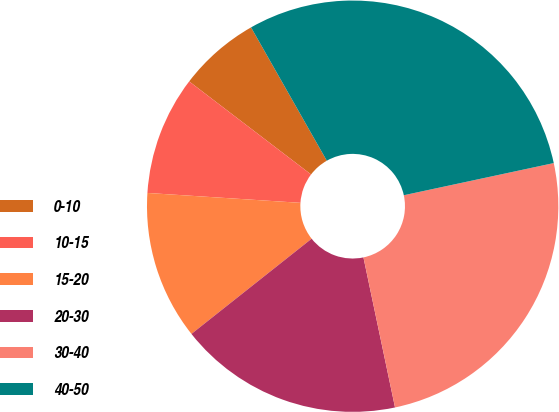Convert chart. <chart><loc_0><loc_0><loc_500><loc_500><pie_chart><fcel>0-10<fcel>10-15<fcel>15-20<fcel>20-30<fcel>30-40<fcel>40-50<nl><fcel>6.4%<fcel>9.35%<fcel>11.69%<fcel>17.64%<fcel>25.06%<fcel>29.86%<nl></chart> 